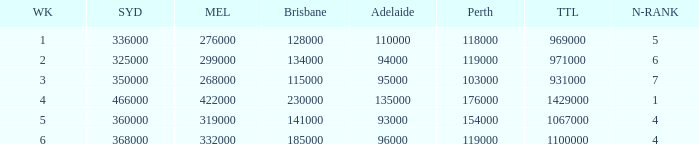What was the rating in Brisbane the week it was 276000 in Melbourne?  128000.0. 